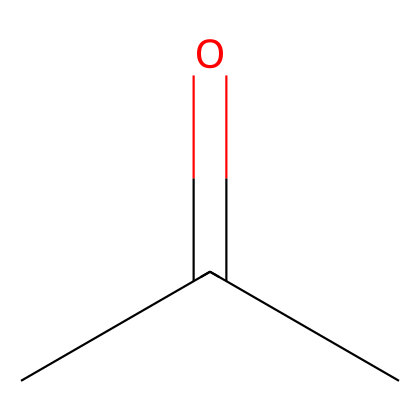What is the common name of this chemical? The chemical has the SMILES representation CC(=O)C, which corresponds to acetone. Acetone is widely known and commonly used as nail polish remover.
Answer: acetone How many carbon atoms are in the structure? Looking at the SMILES representation CC(=O)C, we identify three carbon atoms (the two 'C's before the carbonyl and the 'C' at the end).
Answer: three Does this chemical contain any functional groups? The structure contains a carbonyl group (C=O), indicated by the '=' in the chemical representation, classifying it as a ketone.
Answer: yes, ketone What is the total number of hydrogen atoms in this molecule? In the given SMILES CC(=O)C, there are three carbon atoms; the typical maximum saturation for carbon is four hydrogens. However, due to the presence of a carbonyl (C=O) which occupies one of the bonding sites, we find there are six hydrogen atoms in total.
Answer: six Is acetone a polar or non-polar solvent? The molecule has a polar functional group (the carbonyl group), which indicates that acetone is a polar solvent. This allows it to dissolve many polar and non-polar substances effectively.
Answer: polar What is the boiling point of this chemical? Acetone has a boiling point of approximately 56°C (132.8°F), which is relevant for its use in various applications like nail polish remover.
Answer: 56°C 